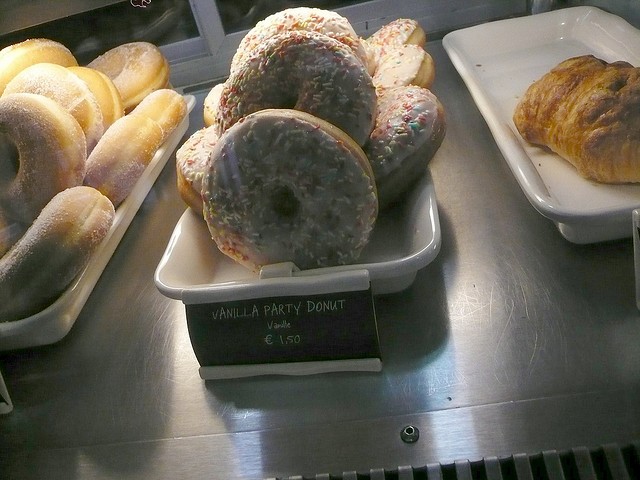<image>What kind of vanilla extract is in the donut? I don't know what kind of vanilla extract is in the donut. It could be natural, vanilla syrup, vanilla party donut, white, imitation, or party. What kind of vanilla extract is in the donut? I don't know what kind of vanilla extract is in the donut. It can be natural, imitation or vanilla syrup. 